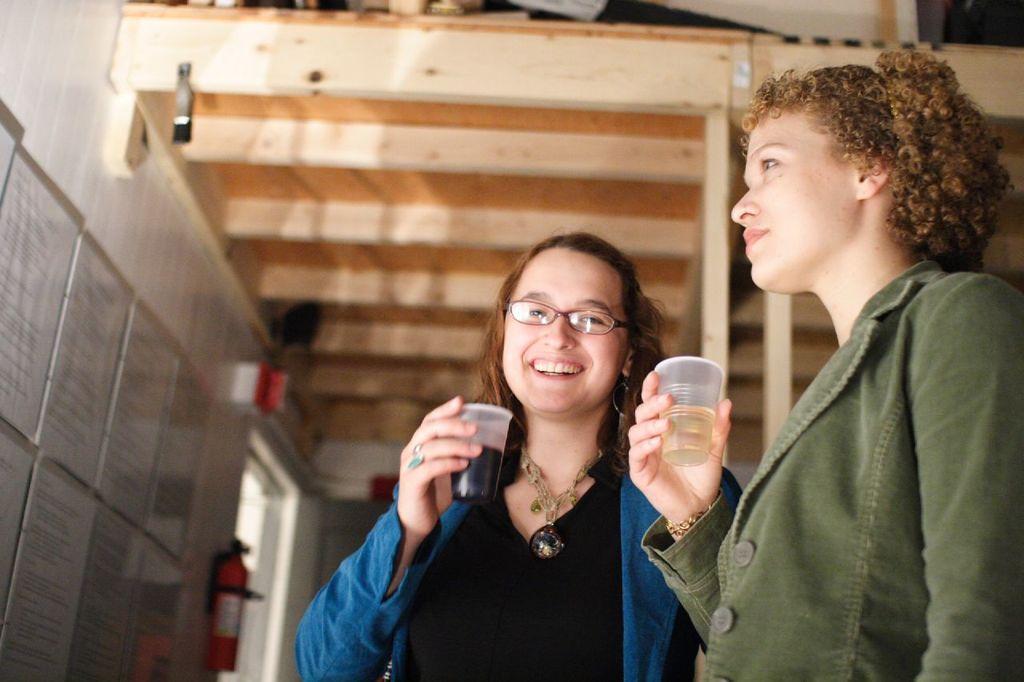Could you give a brief overview of what you see in this image? This is the picture of a room. On the right side of the image there is a woman standing and holding the glass and there is a woman standing and smiling and she is holding the glass. On the left side of the image there is a board and there is a fire extinguisher on the wall. 